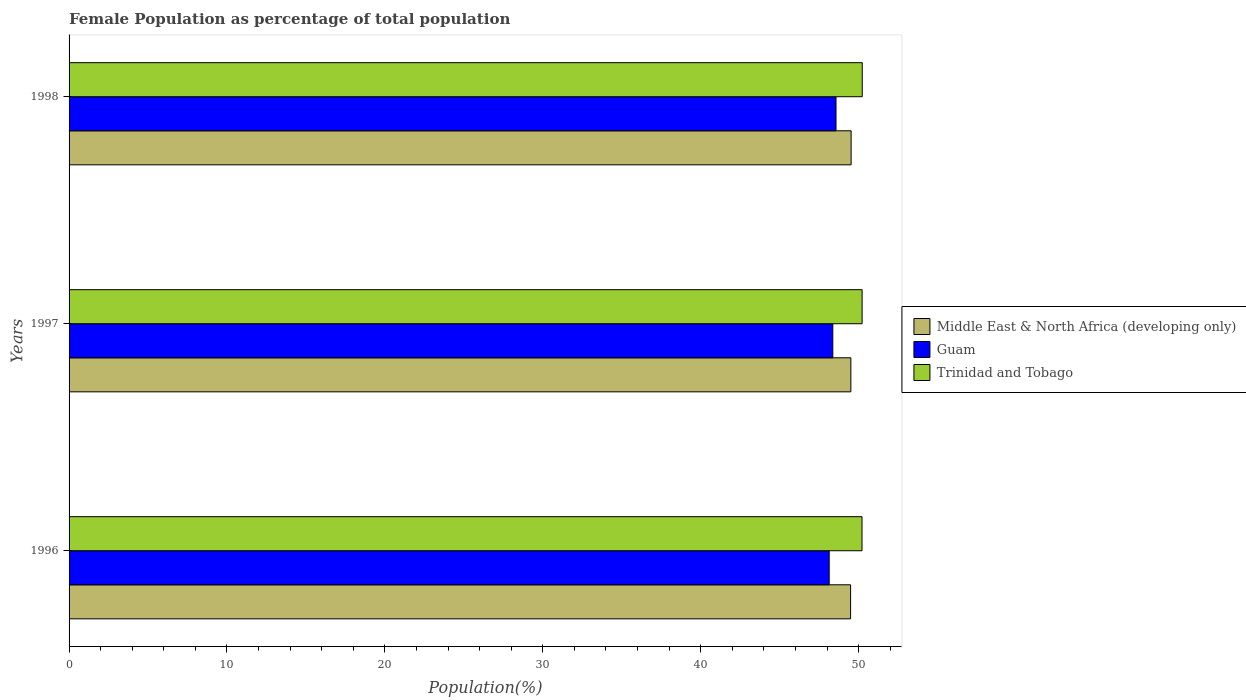How many groups of bars are there?
Offer a very short reply. 3. Are the number of bars on each tick of the Y-axis equal?
Keep it short and to the point. Yes. How many bars are there on the 1st tick from the bottom?
Offer a terse response. 3. What is the label of the 2nd group of bars from the top?
Make the answer very short. 1997. In how many cases, is the number of bars for a given year not equal to the number of legend labels?
Provide a succinct answer. 0. What is the female population in in Guam in 1998?
Offer a terse response. 48.57. Across all years, what is the maximum female population in in Trinidad and Tobago?
Ensure brevity in your answer.  50.23. Across all years, what is the minimum female population in in Middle East & North Africa (developing only)?
Ensure brevity in your answer.  49.49. In which year was the female population in in Trinidad and Tobago maximum?
Give a very brief answer. 1998. What is the total female population in in Middle East & North Africa (developing only) in the graph?
Make the answer very short. 148.53. What is the difference between the female population in in Trinidad and Tobago in 1996 and that in 1998?
Ensure brevity in your answer.  -0.02. What is the difference between the female population in in Guam in 1996 and the female population in in Middle East & North Africa (developing only) in 1998?
Offer a terse response. -1.39. What is the average female population in in Guam per year?
Keep it short and to the point. 48.36. In the year 1998, what is the difference between the female population in in Guam and female population in in Trinidad and Tobago?
Give a very brief answer. -1.66. In how many years, is the female population in in Middle East & North Africa (developing only) greater than 32 %?
Give a very brief answer. 3. What is the ratio of the female population in in Trinidad and Tobago in 1996 to that in 1997?
Your answer should be compact. 1. Is the female population in in Middle East & North Africa (developing only) in 1997 less than that in 1998?
Ensure brevity in your answer.  Yes. What is the difference between the highest and the second highest female population in in Guam?
Your response must be concise. 0.2. What is the difference between the highest and the lowest female population in in Trinidad and Tobago?
Provide a succinct answer. 0.02. In how many years, is the female population in in Middle East & North Africa (developing only) greater than the average female population in in Middle East & North Africa (developing only) taken over all years?
Your answer should be very brief. 1. Is the sum of the female population in in Guam in 1997 and 1998 greater than the maximum female population in in Trinidad and Tobago across all years?
Your answer should be very brief. Yes. What does the 2nd bar from the top in 1998 represents?
Keep it short and to the point. Guam. What does the 3rd bar from the bottom in 1996 represents?
Your answer should be very brief. Trinidad and Tobago. How many bars are there?
Provide a succinct answer. 9. Are all the bars in the graph horizontal?
Provide a short and direct response. Yes. How many years are there in the graph?
Offer a very short reply. 3. What is the difference between two consecutive major ticks on the X-axis?
Keep it short and to the point. 10. Does the graph contain any zero values?
Provide a succinct answer. No. Does the graph contain grids?
Offer a very short reply. No. What is the title of the graph?
Offer a very short reply. Female Population as percentage of total population. What is the label or title of the X-axis?
Offer a terse response. Population(%). What is the Population(%) of Middle East & North Africa (developing only) in 1996?
Your answer should be compact. 49.49. What is the Population(%) in Guam in 1996?
Your answer should be compact. 48.14. What is the Population(%) of Trinidad and Tobago in 1996?
Offer a terse response. 50.22. What is the Population(%) of Middle East & North Africa (developing only) in 1997?
Your answer should be very brief. 49.51. What is the Population(%) of Guam in 1997?
Offer a terse response. 48.37. What is the Population(%) of Trinidad and Tobago in 1997?
Your answer should be compact. 50.22. What is the Population(%) of Middle East & North Africa (developing only) in 1998?
Your response must be concise. 49.53. What is the Population(%) of Guam in 1998?
Provide a short and direct response. 48.57. What is the Population(%) of Trinidad and Tobago in 1998?
Your answer should be compact. 50.23. Across all years, what is the maximum Population(%) in Middle East & North Africa (developing only)?
Keep it short and to the point. 49.53. Across all years, what is the maximum Population(%) in Guam?
Your answer should be compact. 48.57. Across all years, what is the maximum Population(%) of Trinidad and Tobago?
Provide a short and direct response. 50.23. Across all years, what is the minimum Population(%) of Middle East & North Africa (developing only)?
Ensure brevity in your answer.  49.49. Across all years, what is the minimum Population(%) in Guam?
Keep it short and to the point. 48.14. Across all years, what is the minimum Population(%) of Trinidad and Tobago?
Make the answer very short. 50.22. What is the total Population(%) of Middle East & North Africa (developing only) in the graph?
Make the answer very short. 148.53. What is the total Population(%) of Guam in the graph?
Your response must be concise. 145.08. What is the total Population(%) of Trinidad and Tobago in the graph?
Offer a very short reply. 150.67. What is the difference between the Population(%) of Middle East & North Africa (developing only) in 1996 and that in 1997?
Keep it short and to the point. -0.02. What is the difference between the Population(%) in Guam in 1996 and that in 1997?
Provide a succinct answer. -0.23. What is the difference between the Population(%) of Trinidad and Tobago in 1996 and that in 1997?
Provide a succinct answer. -0.01. What is the difference between the Population(%) of Middle East & North Africa (developing only) in 1996 and that in 1998?
Your answer should be very brief. -0.03. What is the difference between the Population(%) of Guam in 1996 and that in 1998?
Offer a terse response. -0.43. What is the difference between the Population(%) in Trinidad and Tobago in 1996 and that in 1998?
Your response must be concise. -0.02. What is the difference between the Population(%) in Middle East & North Africa (developing only) in 1997 and that in 1998?
Ensure brevity in your answer.  -0.02. What is the difference between the Population(%) in Guam in 1997 and that in 1998?
Provide a short and direct response. -0.2. What is the difference between the Population(%) of Trinidad and Tobago in 1997 and that in 1998?
Offer a very short reply. -0.01. What is the difference between the Population(%) of Middle East & North Africa (developing only) in 1996 and the Population(%) of Guam in 1997?
Your answer should be very brief. 1.13. What is the difference between the Population(%) in Middle East & North Africa (developing only) in 1996 and the Population(%) in Trinidad and Tobago in 1997?
Give a very brief answer. -0.73. What is the difference between the Population(%) of Guam in 1996 and the Population(%) of Trinidad and Tobago in 1997?
Give a very brief answer. -2.09. What is the difference between the Population(%) in Middle East & North Africa (developing only) in 1996 and the Population(%) in Guam in 1998?
Keep it short and to the point. 0.92. What is the difference between the Population(%) of Middle East & North Africa (developing only) in 1996 and the Population(%) of Trinidad and Tobago in 1998?
Provide a succinct answer. -0.74. What is the difference between the Population(%) in Guam in 1996 and the Population(%) in Trinidad and Tobago in 1998?
Provide a short and direct response. -2.09. What is the difference between the Population(%) in Middle East & North Africa (developing only) in 1997 and the Population(%) in Guam in 1998?
Your answer should be compact. 0.94. What is the difference between the Population(%) in Middle East & North Africa (developing only) in 1997 and the Population(%) in Trinidad and Tobago in 1998?
Provide a succinct answer. -0.72. What is the difference between the Population(%) of Guam in 1997 and the Population(%) of Trinidad and Tobago in 1998?
Give a very brief answer. -1.86. What is the average Population(%) in Middle East & North Africa (developing only) per year?
Offer a very short reply. 49.51. What is the average Population(%) in Guam per year?
Your response must be concise. 48.36. What is the average Population(%) of Trinidad and Tobago per year?
Give a very brief answer. 50.22. In the year 1996, what is the difference between the Population(%) of Middle East & North Africa (developing only) and Population(%) of Guam?
Ensure brevity in your answer.  1.36. In the year 1996, what is the difference between the Population(%) in Middle East & North Africa (developing only) and Population(%) in Trinidad and Tobago?
Ensure brevity in your answer.  -0.72. In the year 1996, what is the difference between the Population(%) in Guam and Population(%) in Trinidad and Tobago?
Your answer should be compact. -2.08. In the year 1997, what is the difference between the Population(%) of Middle East & North Africa (developing only) and Population(%) of Guam?
Make the answer very short. 1.14. In the year 1997, what is the difference between the Population(%) of Middle East & North Africa (developing only) and Population(%) of Trinidad and Tobago?
Offer a terse response. -0.71. In the year 1997, what is the difference between the Population(%) of Guam and Population(%) of Trinidad and Tobago?
Provide a short and direct response. -1.86. In the year 1998, what is the difference between the Population(%) in Middle East & North Africa (developing only) and Population(%) in Guam?
Offer a very short reply. 0.96. In the year 1998, what is the difference between the Population(%) of Middle East & North Africa (developing only) and Population(%) of Trinidad and Tobago?
Your answer should be very brief. -0.71. In the year 1998, what is the difference between the Population(%) in Guam and Population(%) in Trinidad and Tobago?
Keep it short and to the point. -1.66. What is the ratio of the Population(%) in Middle East & North Africa (developing only) in 1996 to that in 1997?
Make the answer very short. 1. What is the ratio of the Population(%) of Guam in 1996 to that in 1997?
Provide a short and direct response. 1. What is the ratio of the Population(%) in Middle East & North Africa (developing only) in 1997 to that in 1998?
Your answer should be very brief. 1. What is the ratio of the Population(%) in Trinidad and Tobago in 1997 to that in 1998?
Your response must be concise. 1. What is the difference between the highest and the second highest Population(%) of Middle East & North Africa (developing only)?
Your answer should be compact. 0.02. What is the difference between the highest and the second highest Population(%) of Guam?
Offer a terse response. 0.2. What is the difference between the highest and the second highest Population(%) in Trinidad and Tobago?
Offer a terse response. 0.01. What is the difference between the highest and the lowest Population(%) in Middle East & North Africa (developing only)?
Offer a very short reply. 0.03. What is the difference between the highest and the lowest Population(%) of Guam?
Offer a terse response. 0.43. What is the difference between the highest and the lowest Population(%) of Trinidad and Tobago?
Keep it short and to the point. 0.02. 